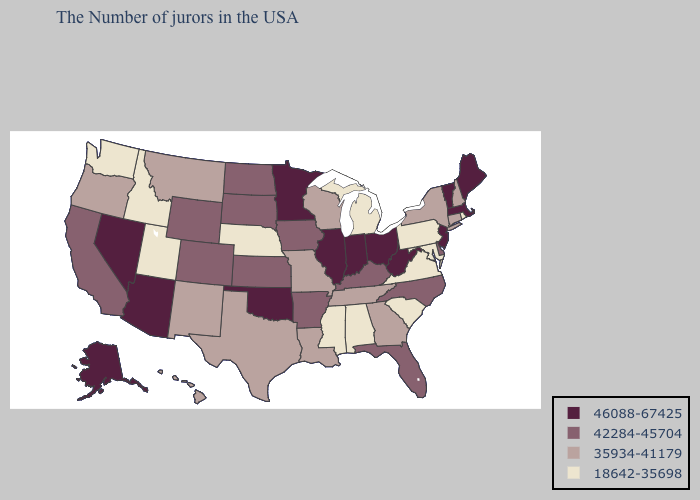What is the highest value in the South ?
Give a very brief answer. 46088-67425. Does Nevada have the highest value in the USA?
Give a very brief answer. Yes. Name the states that have a value in the range 42284-45704?
Answer briefly. Delaware, North Carolina, Florida, Kentucky, Arkansas, Iowa, Kansas, South Dakota, North Dakota, Wyoming, Colorado, California. Name the states that have a value in the range 42284-45704?
Short answer required. Delaware, North Carolina, Florida, Kentucky, Arkansas, Iowa, Kansas, South Dakota, North Dakota, Wyoming, Colorado, California. How many symbols are there in the legend?
Keep it brief. 4. Name the states that have a value in the range 42284-45704?
Be succinct. Delaware, North Carolina, Florida, Kentucky, Arkansas, Iowa, Kansas, South Dakota, North Dakota, Wyoming, Colorado, California. What is the value of Missouri?
Give a very brief answer. 35934-41179. What is the lowest value in the USA?
Quick response, please. 18642-35698. Is the legend a continuous bar?
Answer briefly. No. Which states have the lowest value in the USA?
Keep it brief. Rhode Island, Maryland, Pennsylvania, Virginia, South Carolina, Michigan, Alabama, Mississippi, Nebraska, Utah, Idaho, Washington. What is the value of New Hampshire?
Be succinct. 35934-41179. Name the states that have a value in the range 18642-35698?
Keep it brief. Rhode Island, Maryland, Pennsylvania, Virginia, South Carolina, Michigan, Alabama, Mississippi, Nebraska, Utah, Idaho, Washington. Name the states that have a value in the range 35934-41179?
Answer briefly. New Hampshire, Connecticut, New York, Georgia, Tennessee, Wisconsin, Louisiana, Missouri, Texas, New Mexico, Montana, Oregon, Hawaii. Name the states that have a value in the range 18642-35698?
Quick response, please. Rhode Island, Maryland, Pennsylvania, Virginia, South Carolina, Michigan, Alabama, Mississippi, Nebraska, Utah, Idaho, Washington. Does Delaware have the same value as Nevada?
Give a very brief answer. No. 